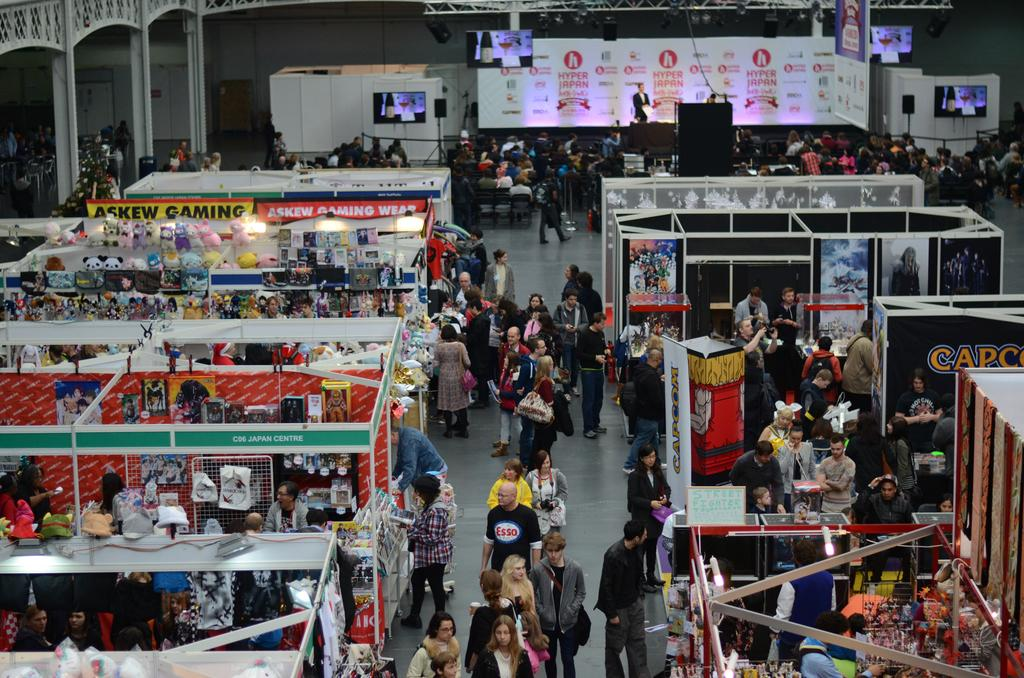What type of setting is depicted in the image? The image shows multiple stalls, suggesting it is a market or fair. How many people can be seen in the image? There are many people in the image. What is located at the top of the image? There is a stage and screens at the top of the image. Can you tell me how many trains are visible in the image? There are no trains present in the image. What type of creature is performing on the stage in the image? There is no creature performing on the stage in the image; the stage and screens are the main focus at the top of the image. 